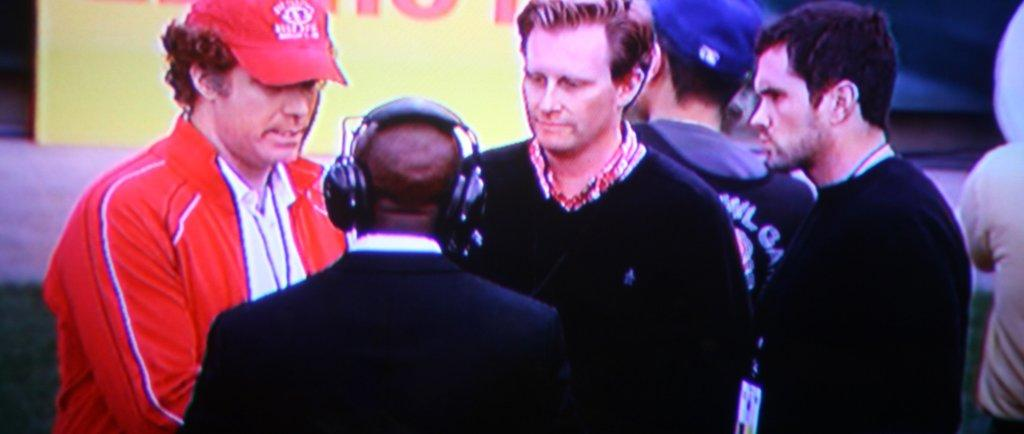How many people are in the group shown in the image? There is a group of people in the image, but the exact number is not specified. What are some people in the group wearing? Some people in the group are wearing caps. Can you describe the person in the middle of the group? The person in the middle of the group is wearing headphones. What can be seen in the background of the image? There is a hoarding visible in the background of the image. How does the cannon in the image affect the air quality? There is no cannon present in the image, so it cannot affect the air quality. 